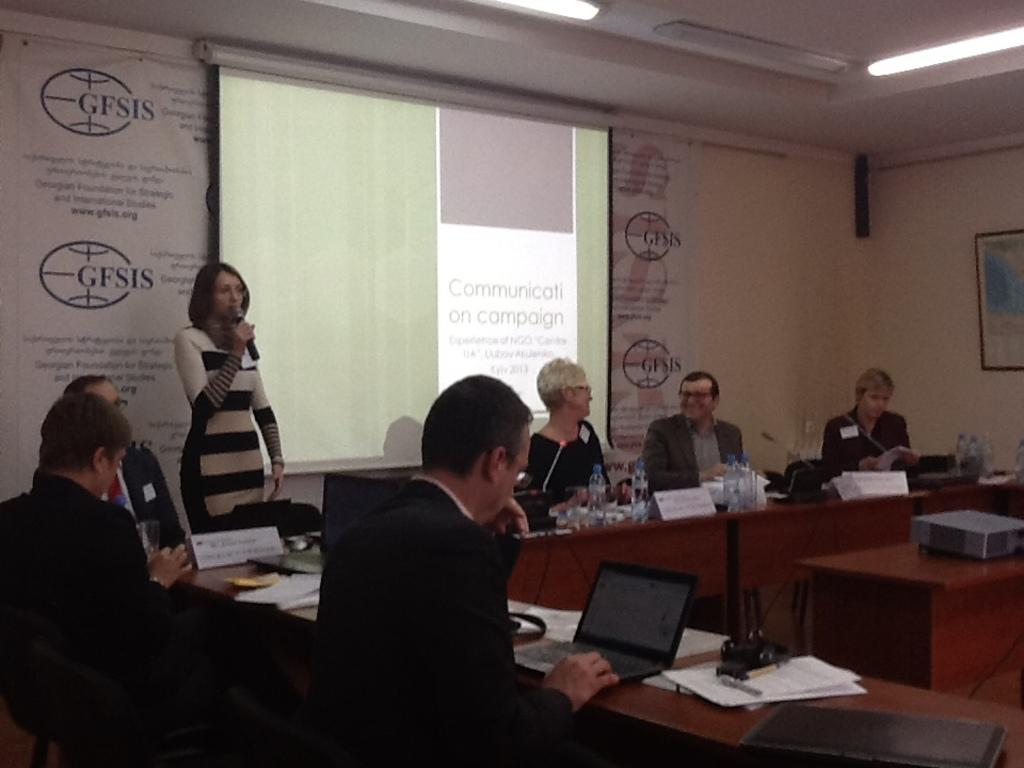What are the people in the image doing? The people in the image are sitting on chairs. What is in front of the people? There is a table in front of the people. What is the woman holding in the image? The woman is holding a microphone. What is the woman doing with the microphone? The woman is talking into the microphone. How many geese are present in the image? There are no geese present in the image. What type of metal is the microphone made of? The type of metal the microphone is made of cannot be determined from the image. 